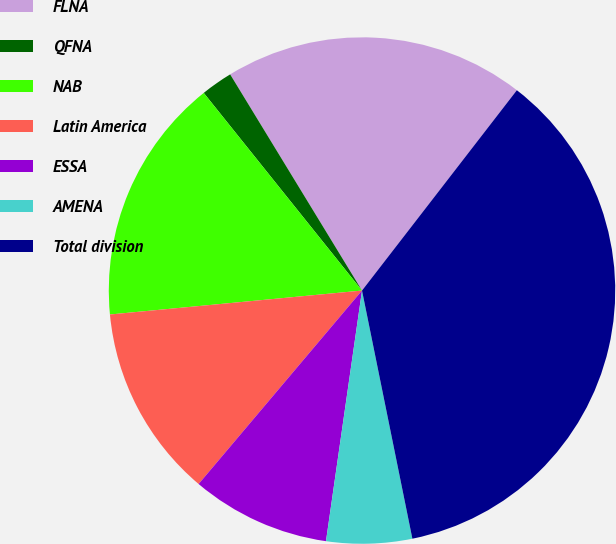Convert chart. <chart><loc_0><loc_0><loc_500><loc_500><pie_chart><fcel>FLNA<fcel>QFNA<fcel>NAB<fcel>Latin America<fcel>ESSA<fcel>AMENA<fcel>Total division<nl><fcel>19.19%<fcel>2.03%<fcel>15.76%<fcel>12.33%<fcel>8.89%<fcel>5.46%<fcel>36.34%<nl></chart> 